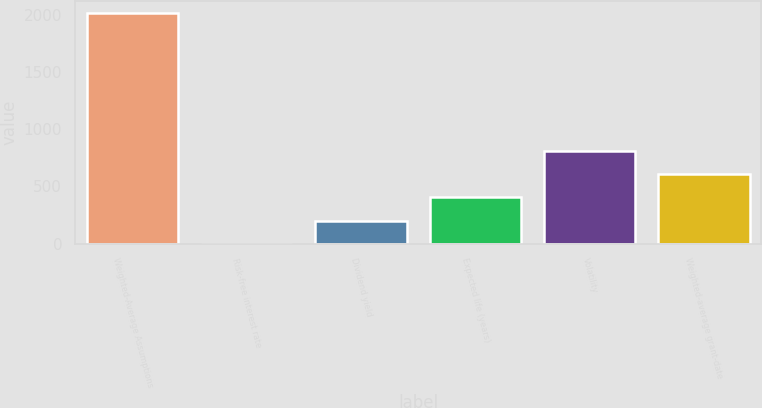<chart> <loc_0><loc_0><loc_500><loc_500><bar_chart><fcel>Weighted-Average Assumptions<fcel>Risk-free interest rate<fcel>Dividend yield<fcel>Expected life (years)<fcel>Volatility<fcel>Weighted-average grant-date<nl><fcel>2015<fcel>1.3<fcel>202.67<fcel>404.04<fcel>806.78<fcel>605.41<nl></chart> 